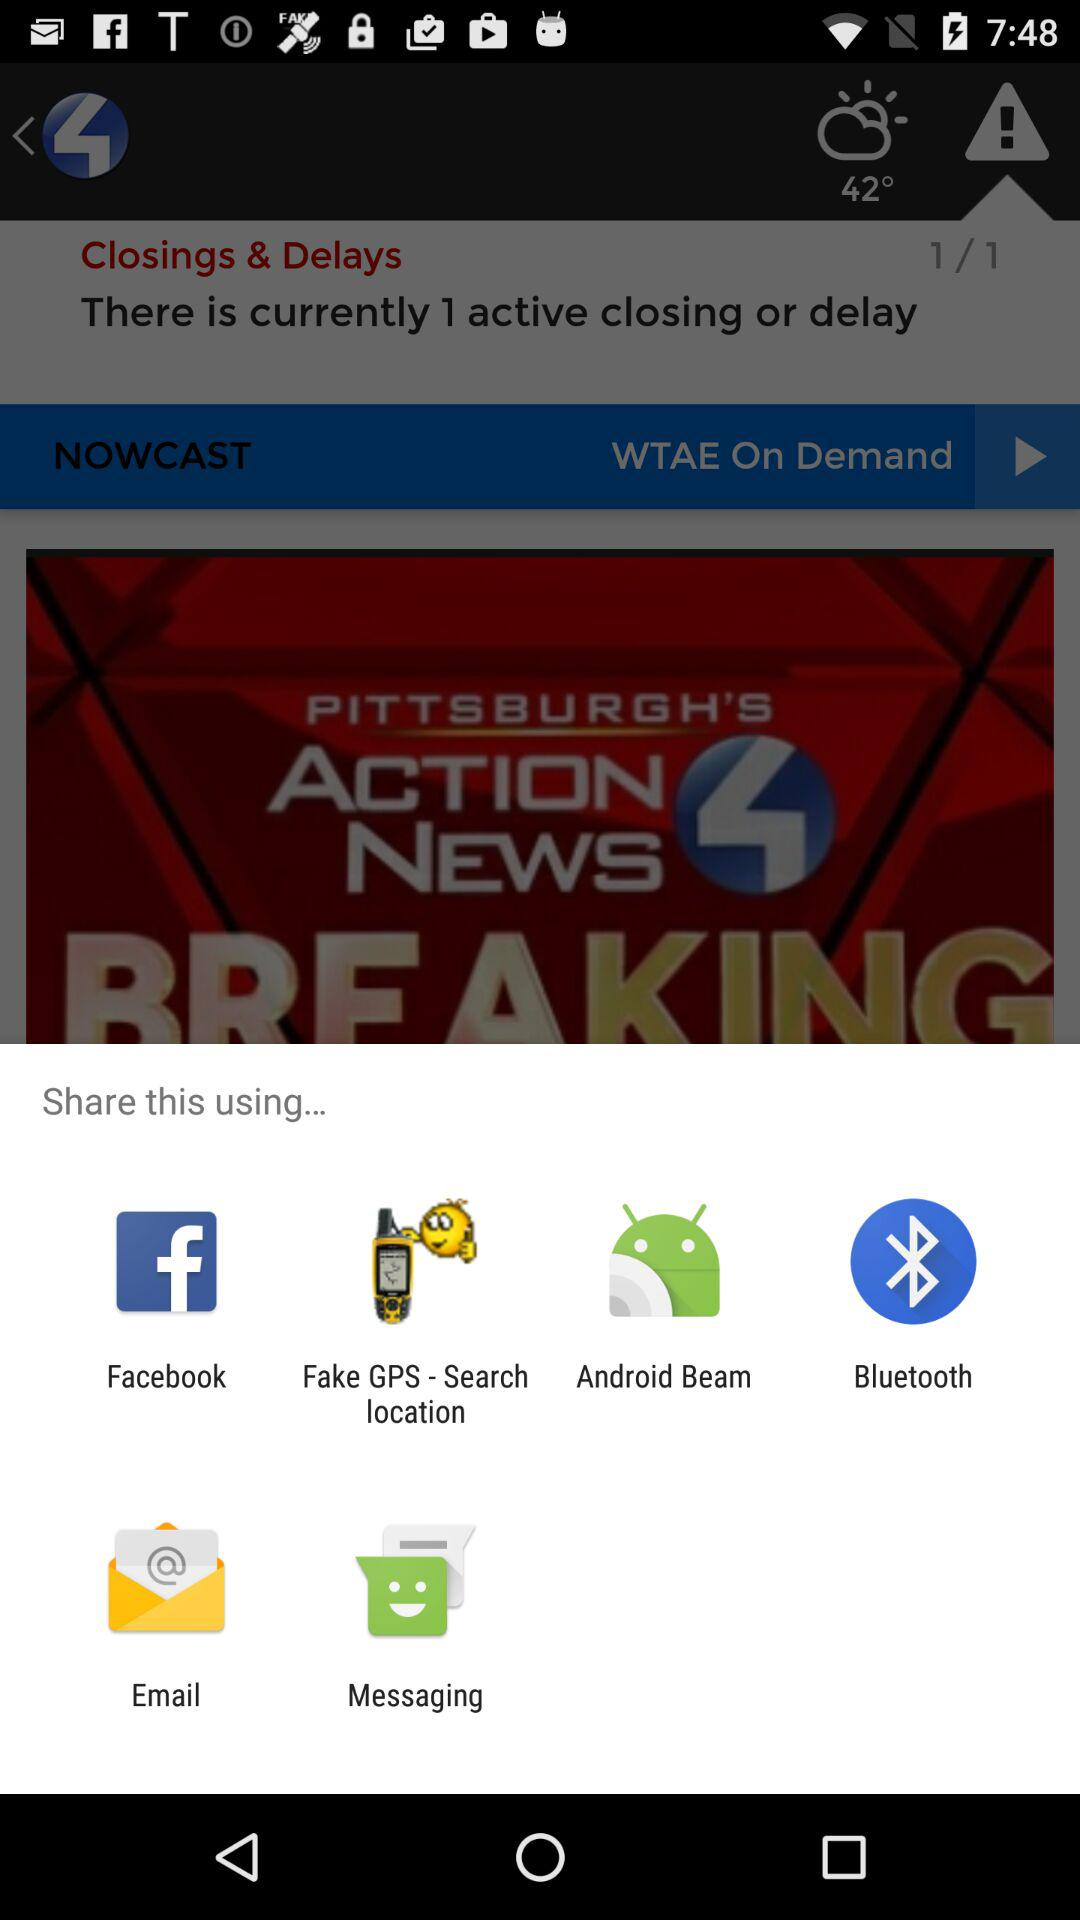How many active closings or delays are there?
Answer the question using a single word or phrase. 1 